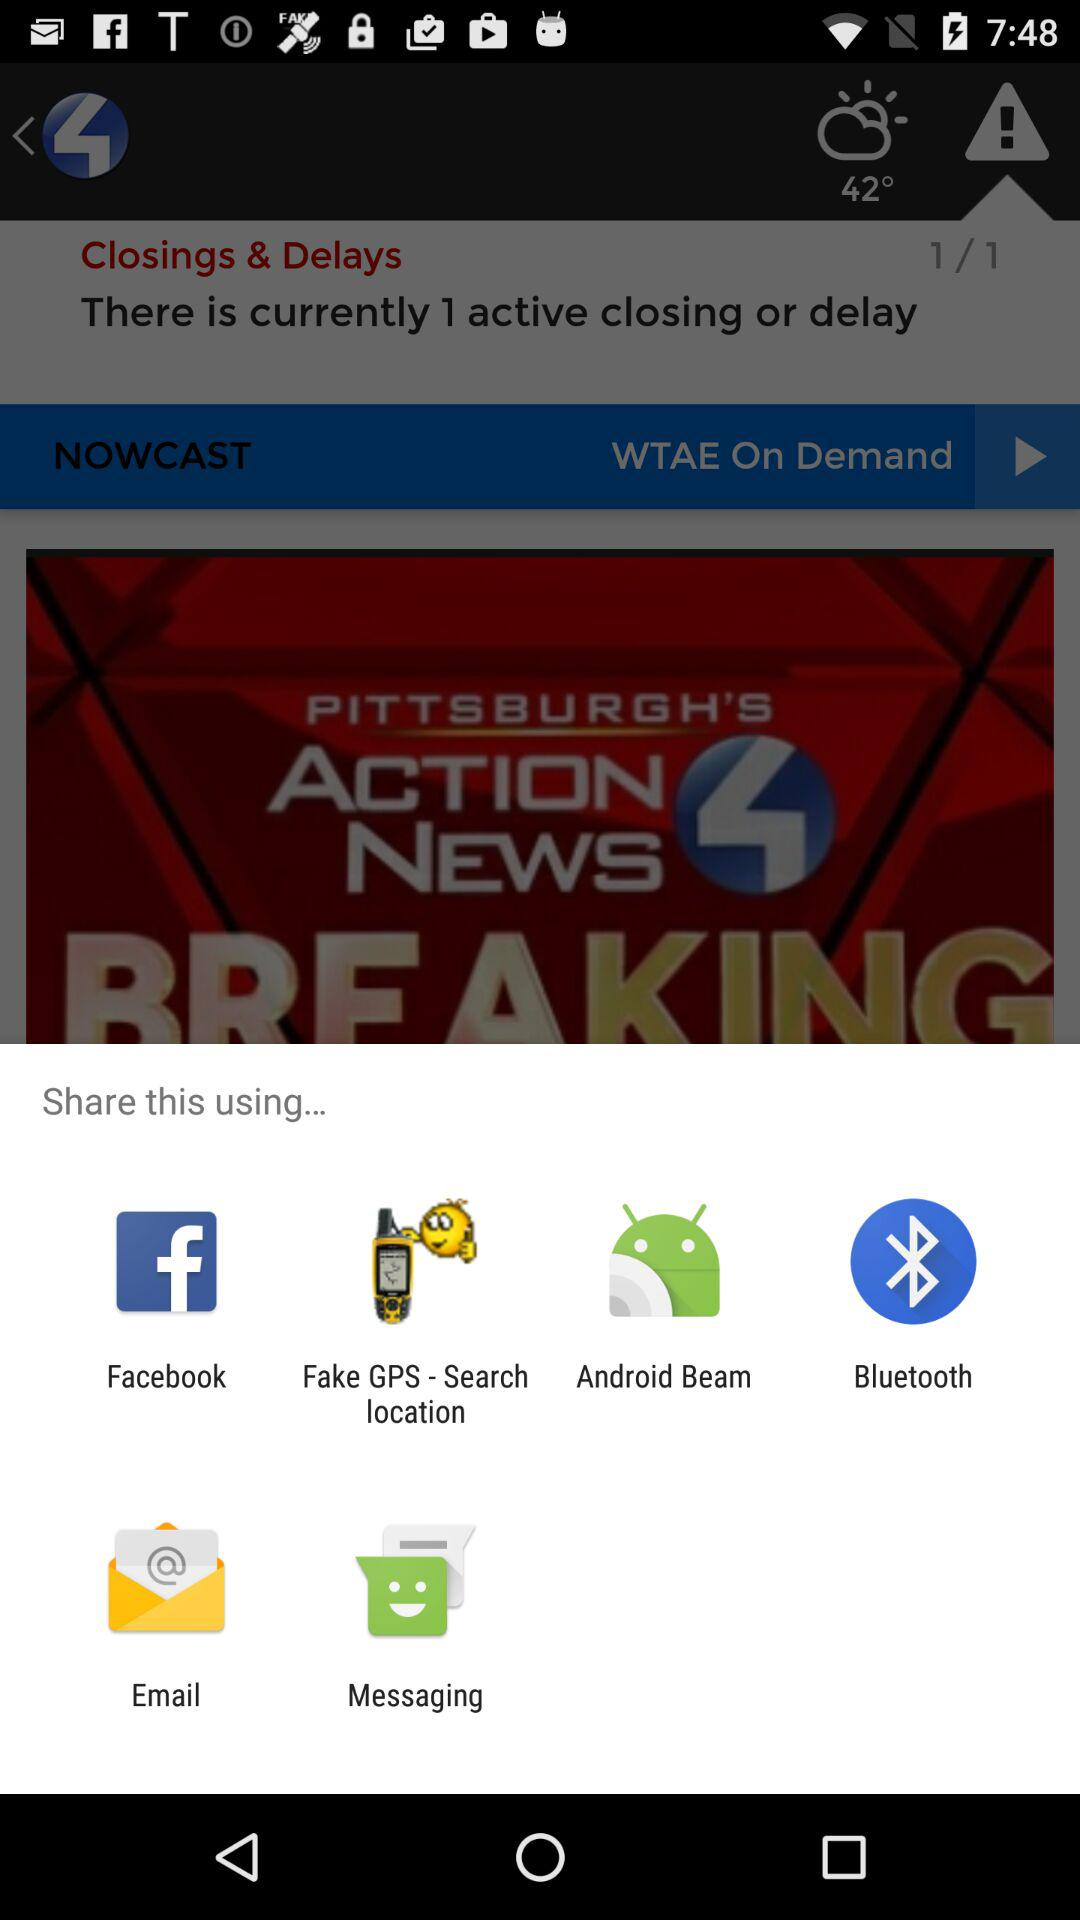How many active closings or delays are there?
Answer the question using a single word or phrase. 1 